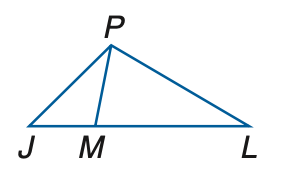Question: In the figure, J M \cong P M and M L \cong P L. If m \angle P L J = 34, find m \angle J P M.
Choices:
A. 34
B. 34.5
C. 36
D. 36.5
Answer with the letter. Answer: D Question: In the figure, J M \cong P M and M L \cong P L. If m \angle P L J = 58, find m \angle P J L.
Choices:
A. 27.5
B. 28.5
C. 29.5
D. 30.5
Answer with the letter. Answer: D 